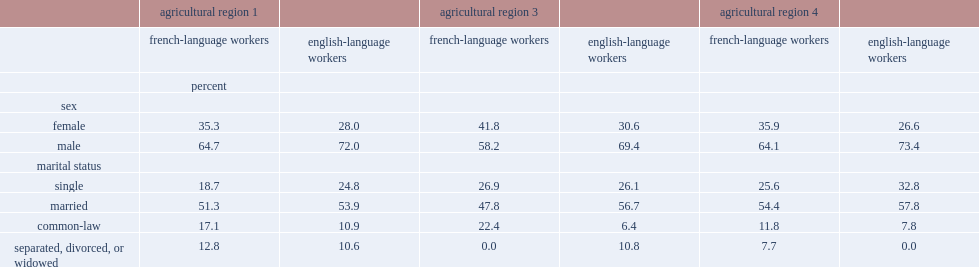Which group of people has more workers in the agricultural secotr in 2011, regardless of the region or language? male or female? Male. Which sector has fewer male agricultural workers?english-language workers or french-language workers? French-language workers. What is the marital status for the majority of new brunswick's agricultural workers, both english-language and french-language workers in 2011? Married. In 2011,which sector of workers were more likely to be in a common-law relationship? french-language workers or english-language workers? French-language workers. 